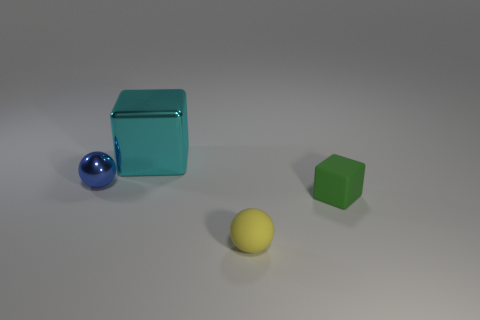Are there any small metal objects of the same color as the big shiny block?
Give a very brief answer. No. There is a yellow object that is the same size as the metal sphere; what is its shape?
Offer a very short reply. Sphere. There is a green matte thing; does it have the same size as the cube on the left side of the green object?
Provide a short and direct response. No. How many objects are either spheres in front of the small metal object or large brown objects?
Your answer should be compact. 1. What shape is the metal object that is right of the tiny metal object?
Your answer should be compact. Cube. Are there the same number of small green rubber things that are to the left of the blue sphere and small things to the left of the big cube?
Ensure brevity in your answer.  No. There is a thing that is both left of the yellow thing and on the right side of the tiny blue thing; what is its color?
Make the answer very short. Cyan. What material is the cube to the right of the cube that is behind the tiny cube?
Offer a terse response. Rubber. Do the blue object and the metal cube have the same size?
Your answer should be compact. No. What number of tiny things are either balls or yellow things?
Give a very brief answer. 2. 